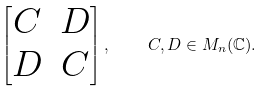Convert formula to latex. <formula><loc_0><loc_0><loc_500><loc_500>\begin{bmatrix} C & D \\ D & C \end{bmatrix} , \quad C , D \in M _ { n } ( \mathbb { C } ) .</formula> 